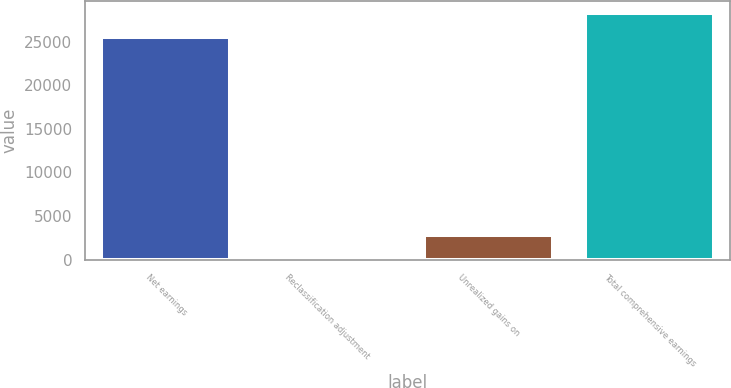Convert chart. <chart><loc_0><loc_0><loc_500><loc_500><bar_chart><fcel>Net earnings<fcel>Reclassification adjustment<fcel>Unrealized gains on<fcel>Total comprehensive earnings<nl><fcel>25621<fcel>116<fcel>2761.7<fcel>28266.7<nl></chart> 